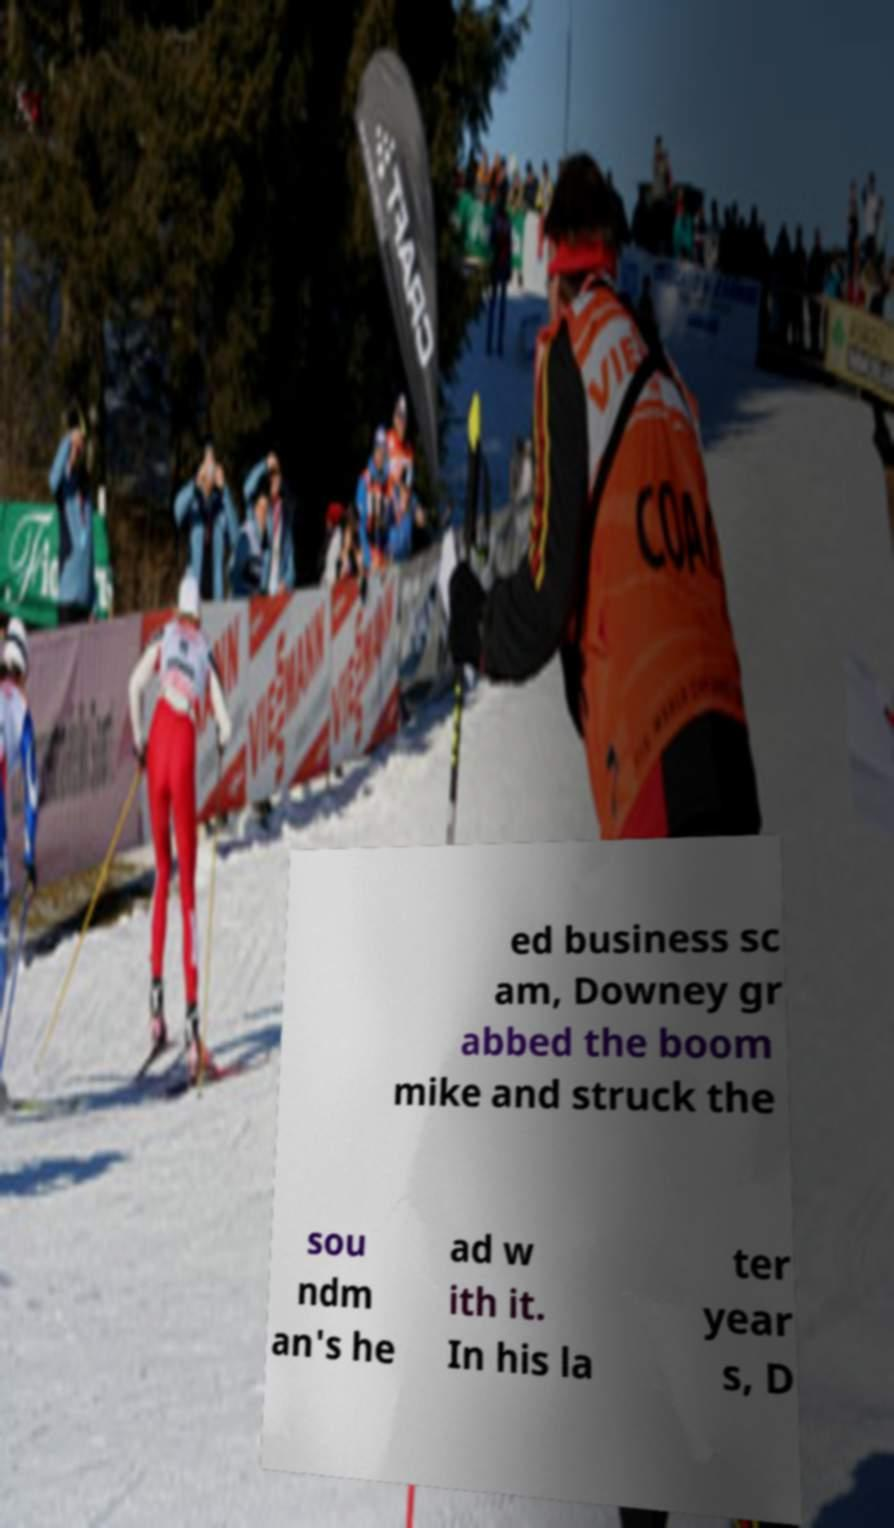I need the written content from this picture converted into text. Can you do that? ed business sc am, Downey gr abbed the boom mike and struck the sou ndm an's he ad w ith it. In his la ter year s, D 